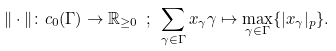<formula> <loc_0><loc_0><loc_500><loc_500>\| \cdot \| \colon c _ { 0 } ( \Gamma ) \rightarrow \mathbb { R } _ { \geq 0 } \ ; \ \sum _ { \gamma \in \Gamma } x _ { \gamma } \gamma \mapsto \max _ { \gamma \in \Gamma } \{ | x _ { \gamma } | _ { p } \} .</formula> 